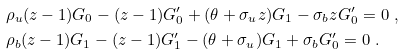Convert formula to latex. <formula><loc_0><loc_0><loc_500><loc_500>& \rho _ { u } ( z - 1 ) G _ { 0 } - ( z - 1 ) G _ { 0 } ^ { \prime } + ( \theta + \sigma _ { u } z ) G _ { 1 } - \sigma _ { b } z G _ { 0 } ^ { \prime } = 0 \ , \\ & \rho _ { b } ( z - 1 ) G _ { 1 } - ( z - 1 ) G _ { 1 } ^ { \prime } - ( \theta + \sigma _ { u } ) G _ { 1 } + \sigma _ { b } G _ { 0 } ^ { \prime } = 0 \ .</formula> 